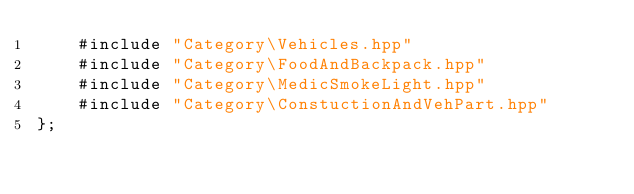<code> <loc_0><loc_0><loc_500><loc_500><_C++_>	#include "Category\Vehicles.hpp"
	#include "Category\FoodAndBackpack.hpp"
	#include "Category\MedicSmokeLight.hpp"
	#include "Category\ConstuctionAndVehPart.hpp"
};
</code> 